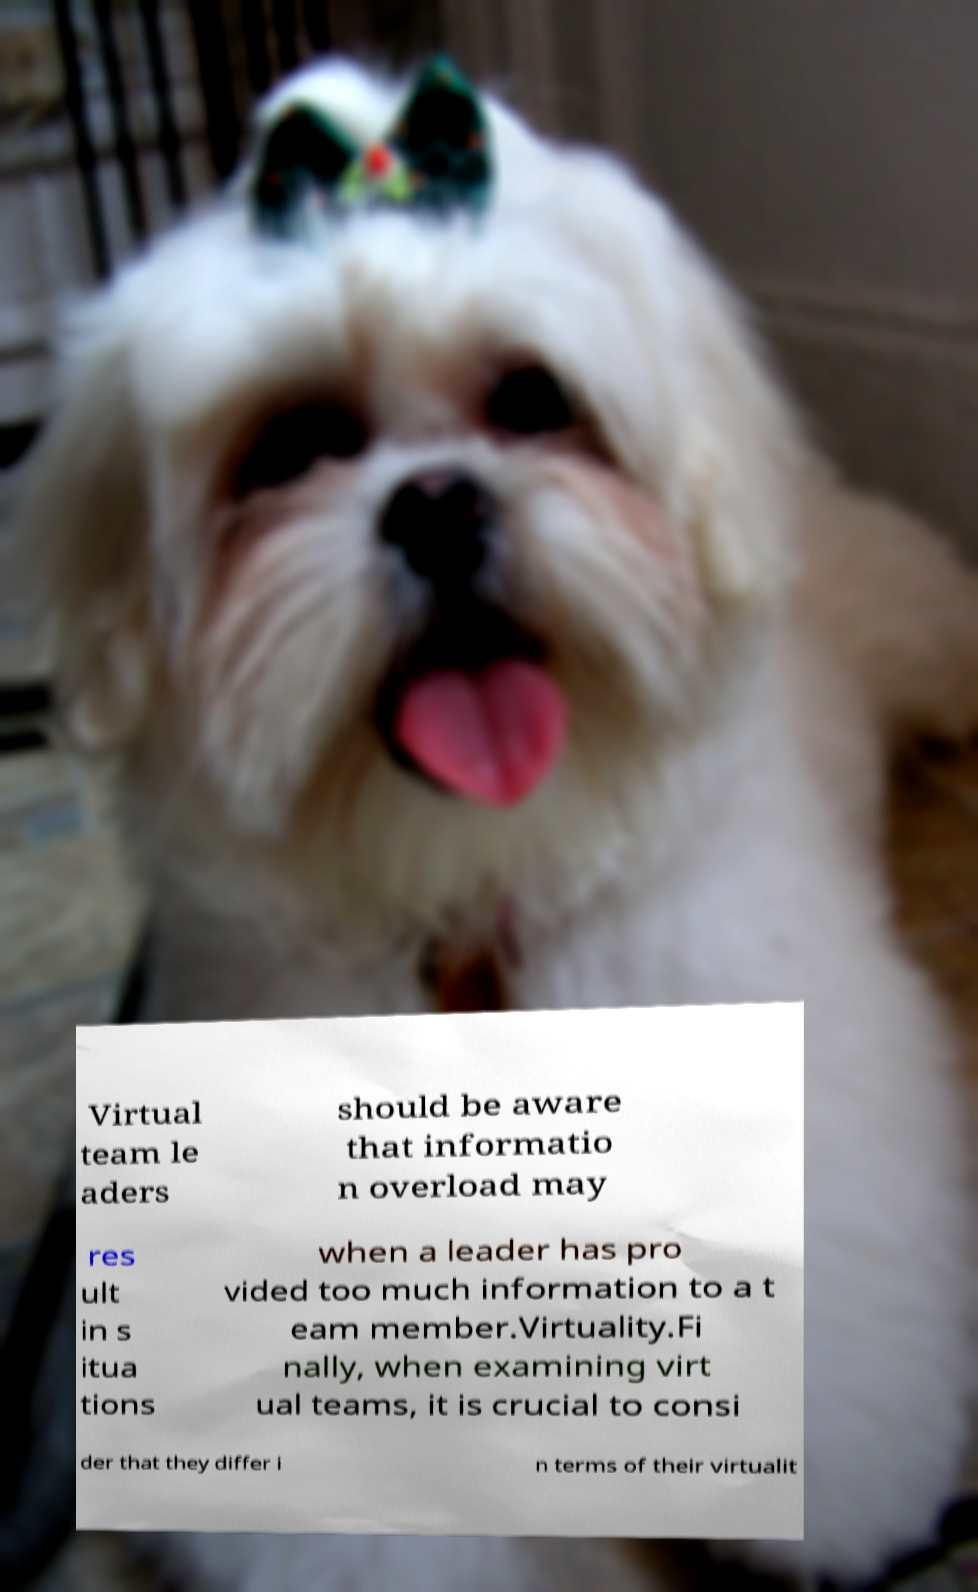Can you read and provide the text displayed in the image?This photo seems to have some interesting text. Can you extract and type it out for me? Virtual team le aders should be aware that informatio n overload may res ult in s itua tions when a leader has pro vided too much information to a t eam member.Virtuality.Fi nally, when examining virt ual teams, it is crucial to consi der that they differ i n terms of their virtualit 